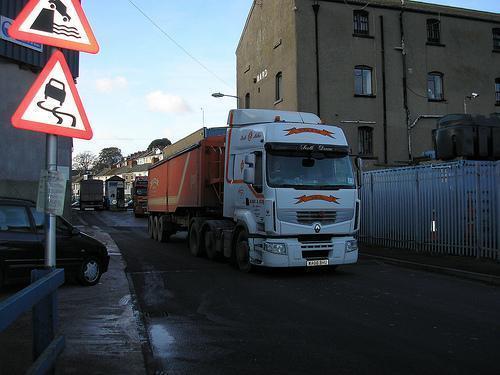How many cars do you see?
Give a very brief answer. 1. 